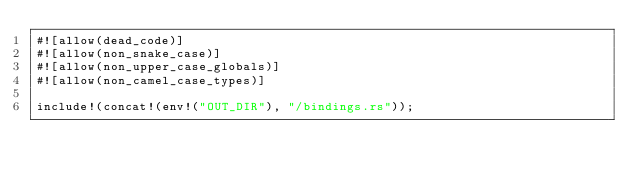<code> <loc_0><loc_0><loc_500><loc_500><_Rust_>#![allow(dead_code)]
#![allow(non_snake_case)]
#![allow(non_upper_case_globals)]
#![allow(non_camel_case_types)]

include!(concat!(env!("OUT_DIR"), "/bindings.rs"));
</code> 